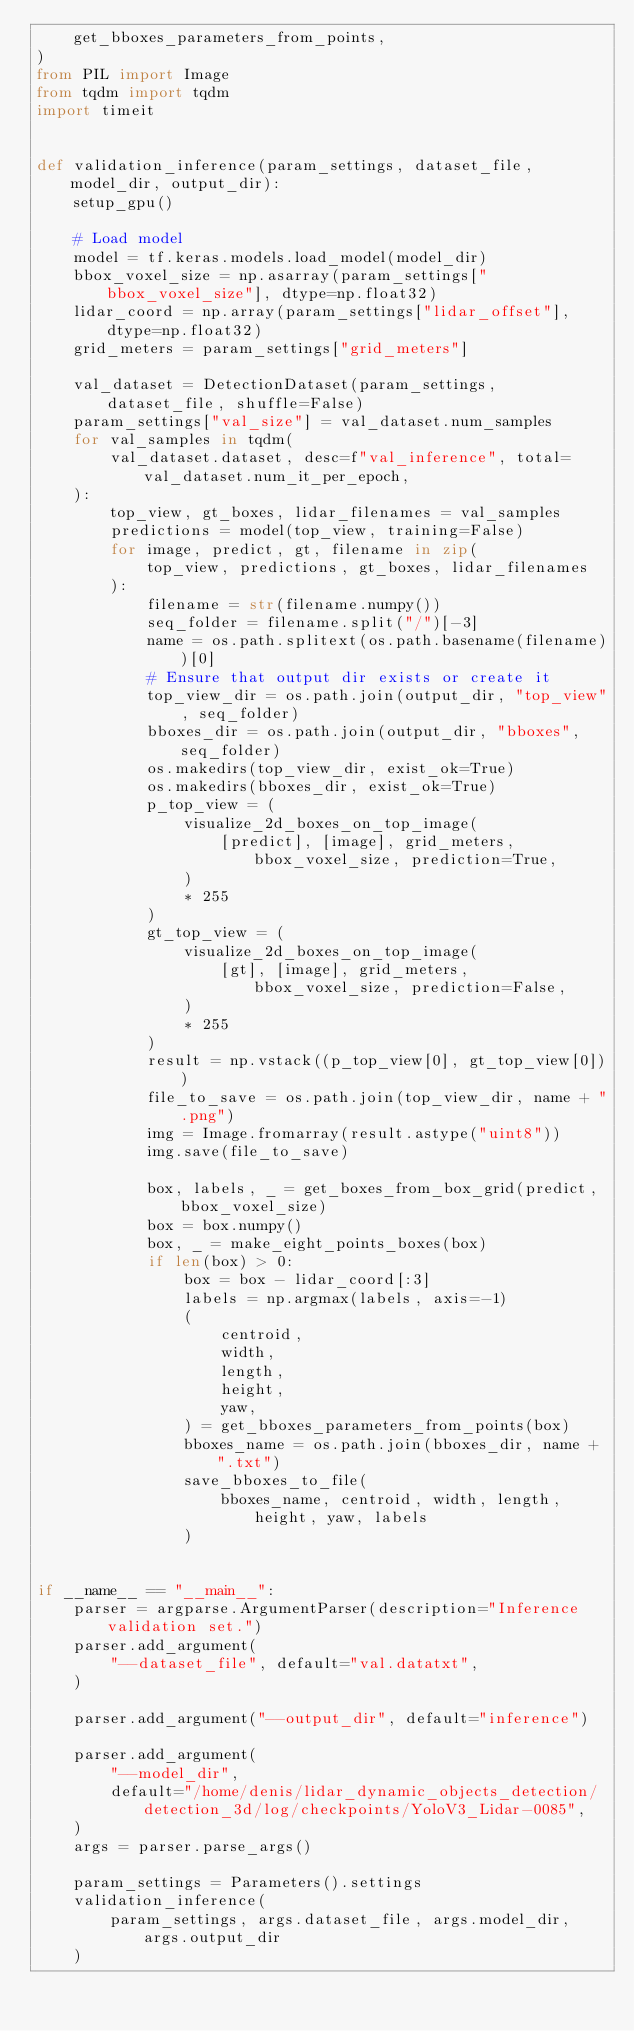<code> <loc_0><loc_0><loc_500><loc_500><_Python_>    get_bboxes_parameters_from_points,
)
from PIL import Image
from tqdm import tqdm
import timeit


def validation_inference(param_settings, dataset_file, model_dir, output_dir):
    setup_gpu()

    # Load model
    model = tf.keras.models.load_model(model_dir)
    bbox_voxel_size = np.asarray(param_settings["bbox_voxel_size"], dtype=np.float32)
    lidar_coord = np.array(param_settings["lidar_offset"], dtype=np.float32)
    grid_meters = param_settings["grid_meters"]

    val_dataset = DetectionDataset(param_settings, dataset_file, shuffle=False)
    param_settings["val_size"] = val_dataset.num_samples
    for val_samples in tqdm(
        val_dataset.dataset, desc=f"val_inference", total=val_dataset.num_it_per_epoch,
    ):
        top_view, gt_boxes, lidar_filenames = val_samples
        predictions = model(top_view, training=False)
        for image, predict, gt, filename in zip(
            top_view, predictions, gt_boxes, lidar_filenames
        ):
            filename = str(filename.numpy())
            seq_folder = filename.split("/")[-3]
            name = os.path.splitext(os.path.basename(filename))[0]
            # Ensure that output dir exists or create it
            top_view_dir = os.path.join(output_dir, "top_view", seq_folder)
            bboxes_dir = os.path.join(output_dir, "bboxes", seq_folder)
            os.makedirs(top_view_dir, exist_ok=True)
            os.makedirs(bboxes_dir, exist_ok=True)
            p_top_view = (
                visualize_2d_boxes_on_top_image(
                    [predict], [image], grid_meters, bbox_voxel_size, prediction=True,
                )
                * 255
            )
            gt_top_view = (
                visualize_2d_boxes_on_top_image(
                    [gt], [image], grid_meters, bbox_voxel_size, prediction=False,
                )
                * 255
            )
            result = np.vstack((p_top_view[0], gt_top_view[0]))
            file_to_save = os.path.join(top_view_dir, name + ".png")
            img = Image.fromarray(result.astype("uint8"))
            img.save(file_to_save)

            box, labels, _ = get_boxes_from_box_grid(predict, bbox_voxel_size)
            box = box.numpy()
            box, _ = make_eight_points_boxes(box)
            if len(box) > 0:
                box = box - lidar_coord[:3]
                labels = np.argmax(labels, axis=-1)
                (
                    centroid,
                    width,
                    length,
                    height,
                    yaw,
                ) = get_bboxes_parameters_from_points(box)
                bboxes_name = os.path.join(bboxes_dir, name + ".txt")
                save_bboxes_to_file(
                    bboxes_name, centroid, width, length, height, yaw, labels
                )


if __name__ == "__main__":
    parser = argparse.ArgumentParser(description="Inference  validation set.")
    parser.add_argument(
        "--dataset_file", default="val.datatxt",
    )

    parser.add_argument("--output_dir", default="inference")

    parser.add_argument(
        "--model_dir",
        default="/home/denis/lidar_dynamic_objects_detection/detection_3d/log/checkpoints/YoloV3_Lidar-0085",
    )
    args = parser.parse_args()

    param_settings = Parameters().settings
    validation_inference(
        param_settings, args.dataset_file, args.model_dir, args.output_dir
    )
</code> 